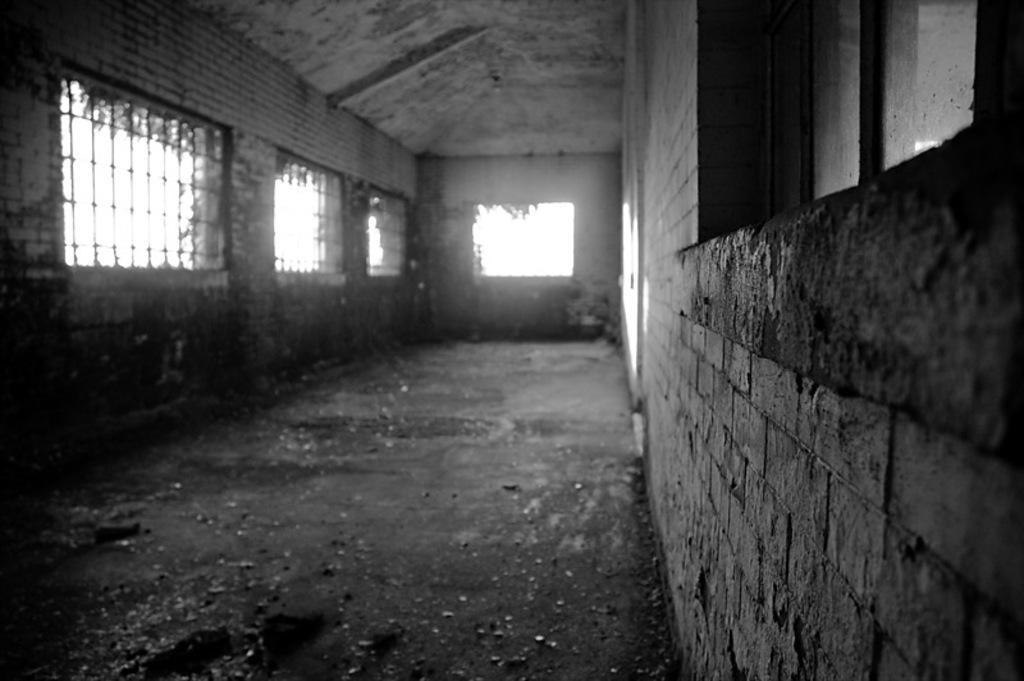Can you describe this image briefly? This is a black and white picture. In this picture we can see the grilles, floor. On the right side of the picture we can see a window and the wall. 